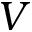Convert formula to latex. <formula><loc_0><loc_0><loc_500><loc_500>V</formula> 